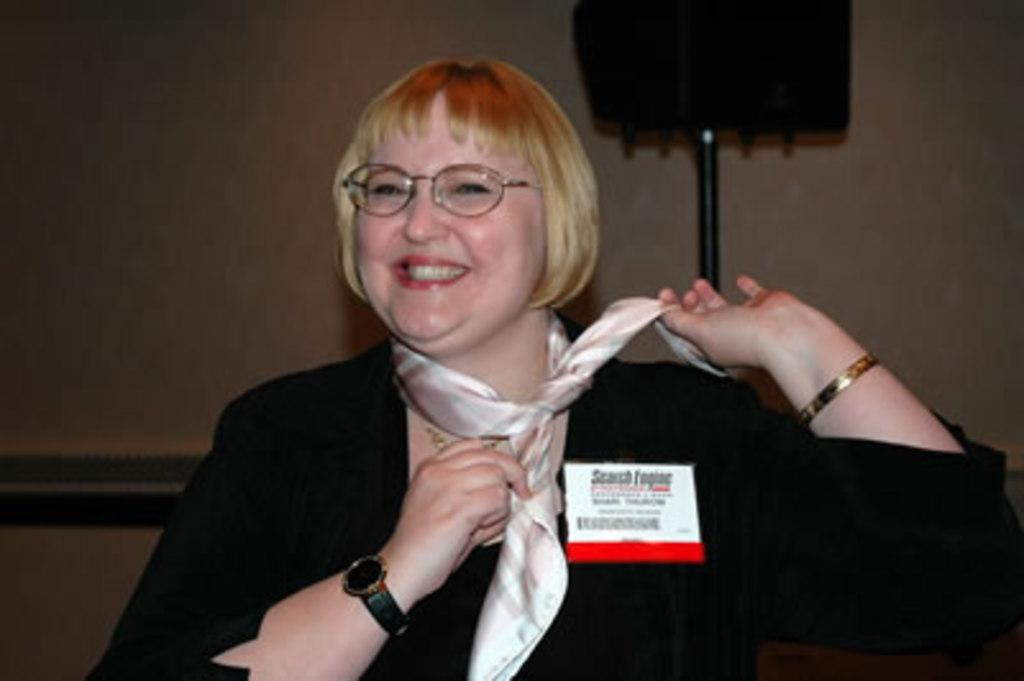Who is present in the room? There is a woman in the room. What is the woman doing? The woman is smiling. What is the woman wearing? The woman is wearing a black dress and a stole. Where is the speaker located in the room? The speaker is at the right back of the room. How many family members are present in the room? The provided facts do not mention any family members, so we cannot determine the number of family members present in the room. Are there any cats visible in the image? There is no mention of cats in the provided facts, so we cannot determine if there are any cats visible in the image. 